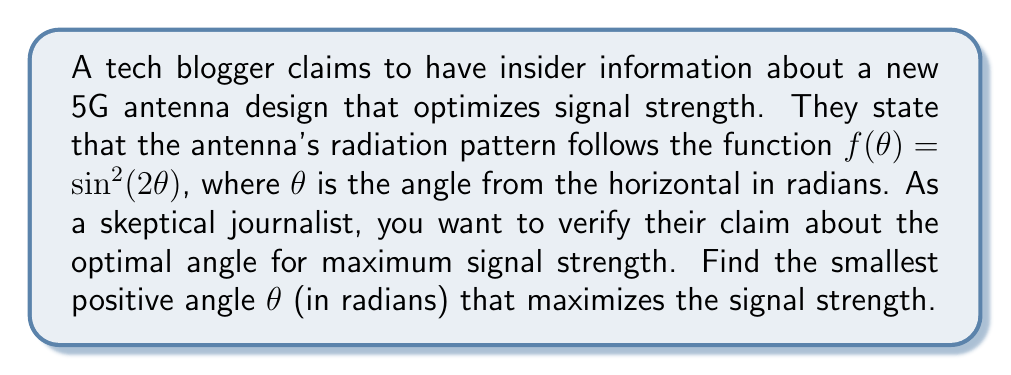Solve this math problem. To find the angle that maximizes the signal strength, we need to find the maximum of the function $f(\theta) = \sin^2(2\theta)$. Let's approach this step-by-step:

1) First, we need to find the derivative of $f(\theta)$:
   $$\frac{d}{d\theta}[\sin^2(2\theta)] = 2\sin(2\theta) \cdot \frac{d}{d\theta}[\sin(2\theta)]$$
   $$= 2\sin(2\theta) \cdot 2\cos(2\theta)$$
   $$= 4\sin(2\theta)\cos(2\theta)$$

2) We can simplify this using the double angle formula for sine:
   $$f'(\theta) = 4\sin(2\theta)\cos(2\theta) = 2\sin(4\theta)$$

3) To find the maximum, we set the derivative to zero:
   $$2\sin(4\theta) = 0$$
   $$\sin(4\theta) = 0$$

4) The solutions to this equation are:
   $$4\theta = n\pi, \text{ where } n \text{ is an integer}$$
   $$\theta = \frac{n\pi}{4}$$

5) The smallest positive angle that satisfies this is when $n = 1$:
   $$\theta = \frac{\pi}{4}$$

6) To confirm this is a maximum (not a minimum), we can check the second derivative:
   $$f''(\theta) = 8\cos(4\theta)$$
   At $\theta = \frac{\pi}{4}$, $f''(\frac{\pi}{4}) = 8\cos(\pi) = -8 < 0$, confirming it's a maximum.

Therefore, the smallest positive angle that maximizes the signal strength is $\frac{\pi}{4}$ radians.
Answer: $\frac{\pi}{4}$ radians 